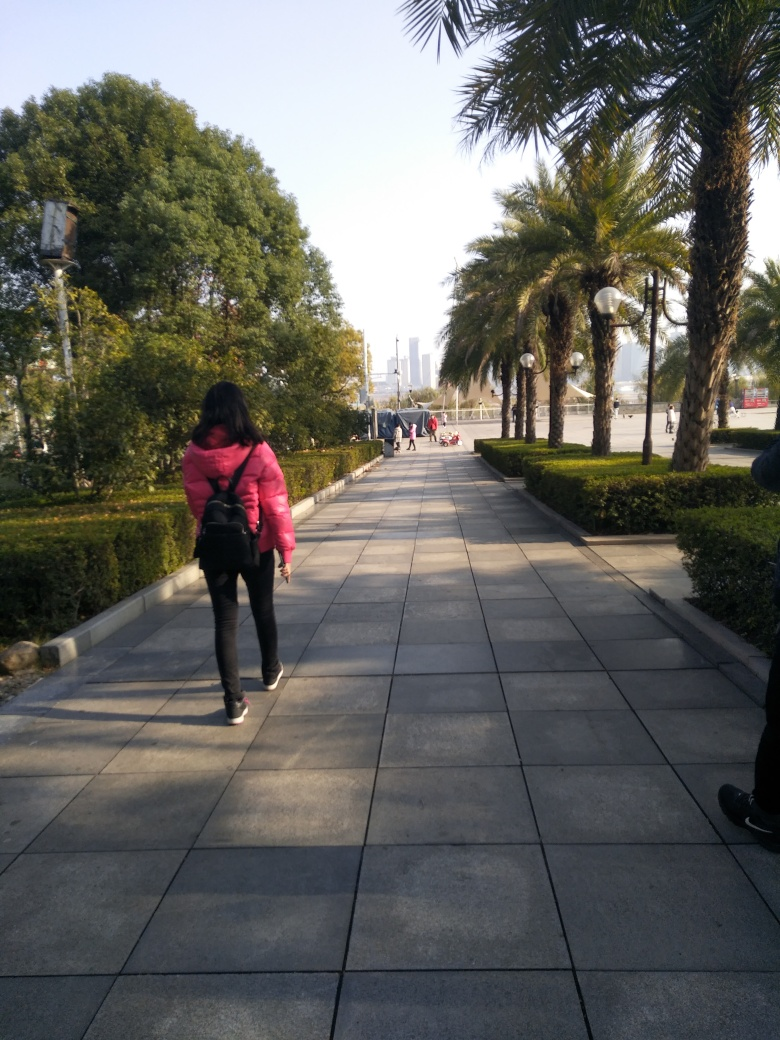What is the overall clarity of this image?
A. Acceptable
B. Poor
C. Unsatisfactory
D. Excellent
Answer with the option's letter from the given choices directly.
 A. 